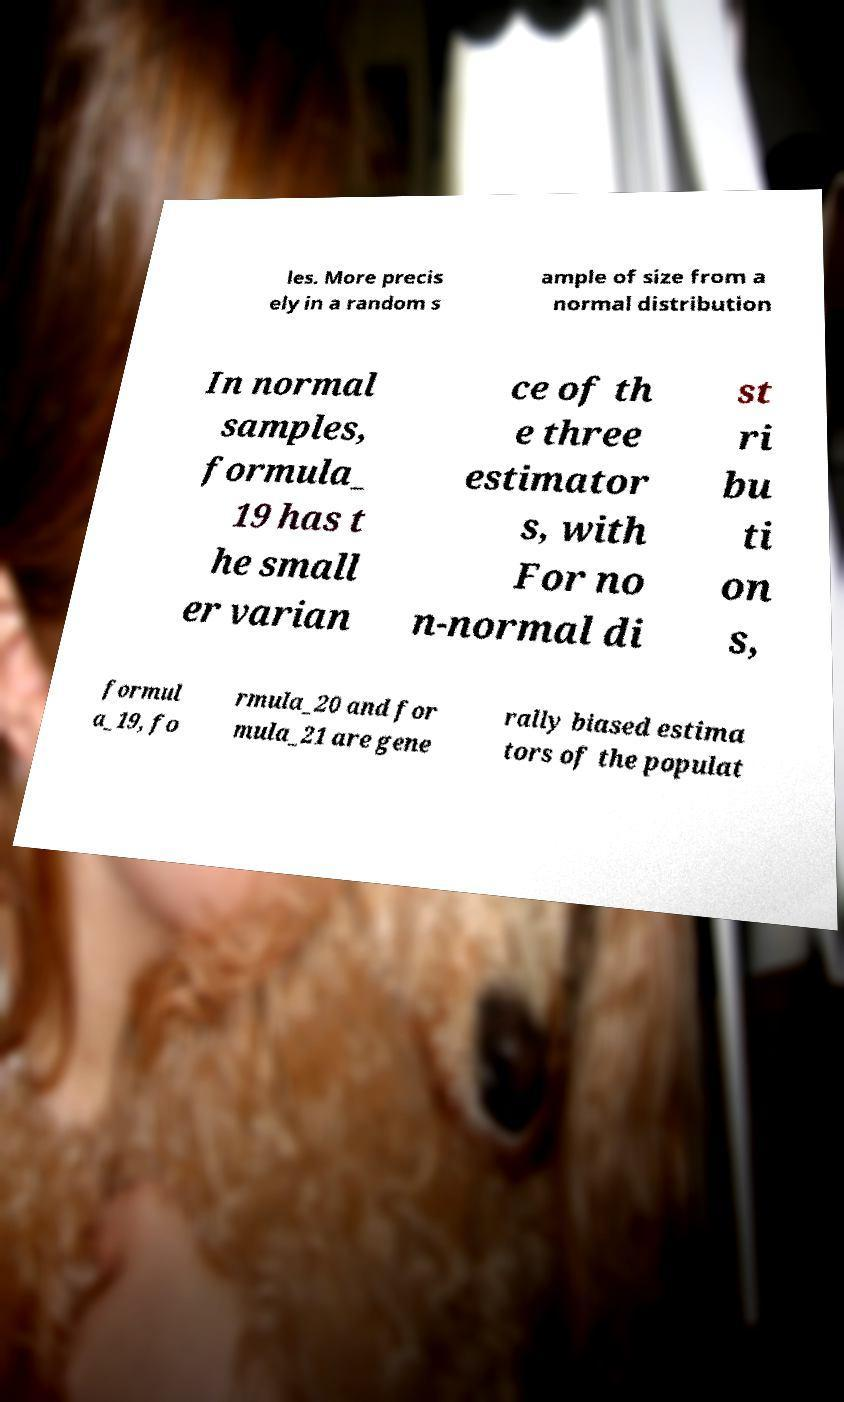Could you assist in decoding the text presented in this image and type it out clearly? les. More precis ely in a random s ample of size from a normal distribution In normal samples, formula_ 19 has t he small er varian ce of th e three estimator s, with For no n-normal di st ri bu ti on s, formul a_19, fo rmula_20 and for mula_21 are gene rally biased estima tors of the populat 